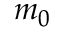<formula> <loc_0><loc_0><loc_500><loc_500>m _ { 0 }</formula> 